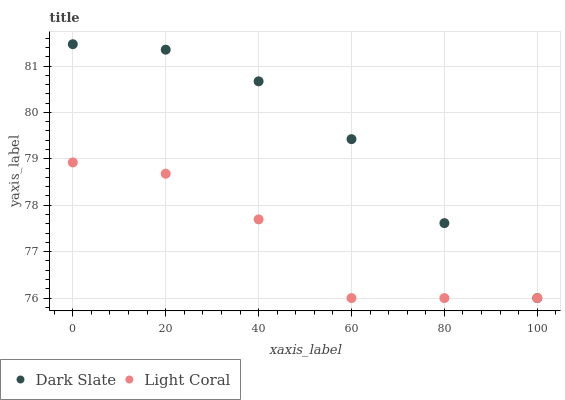Does Light Coral have the minimum area under the curve?
Answer yes or no. Yes. Does Dark Slate have the maximum area under the curve?
Answer yes or no. Yes. Does Dark Slate have the minimum area under the curve?
Answer yes or no. No. Is Dark Slate the smoothest?
Answer yes or no. Yes. Is Light Coral the roughest?
Answer yes or no. Yes. Is Dark Slate the roughest?
Answer yes or no. No. Does Light Coral have the lowest value?
Answer yes or no. Yes. Does Dark Slate have the highest value?
Answer yes or no. Yes. Does Dark Slate intersect Light Coral?
Answer yes or no. Yes. Is Dark Slate less than Light Coral?
Answer yes or no. No. Is Dark Slate greater than Light Coral?
Answer yes or no. No. 